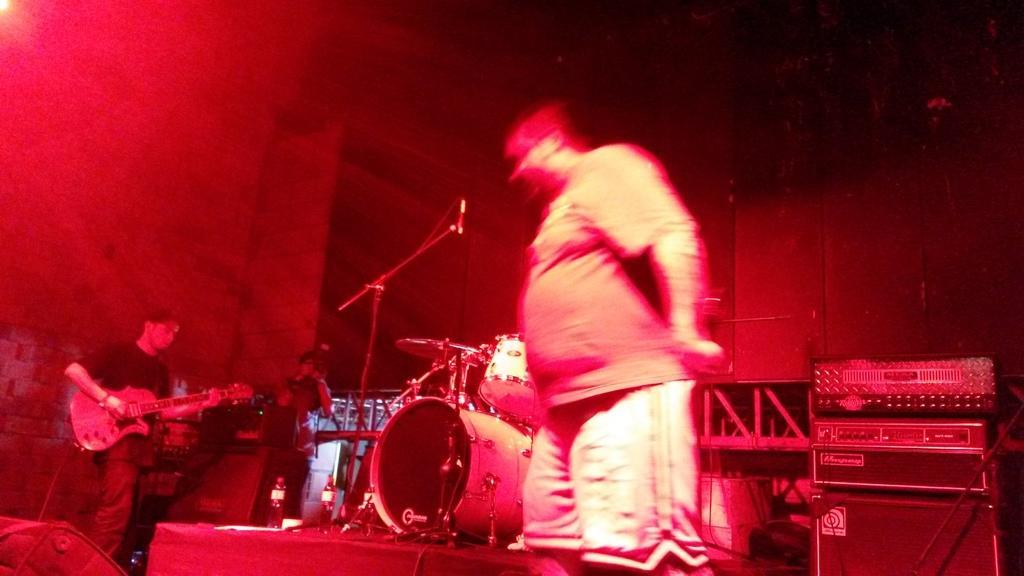Could you give a brief overview of what you see in this image? There are three persons in this image at the left side the man is standing and holding a guitar in his hand. In the center a man is holding a camera and clicking the picture. There is a musical drum on the stage. At the right side a man is standing. In the background there is a stage and there are two boxes kept on the table. 